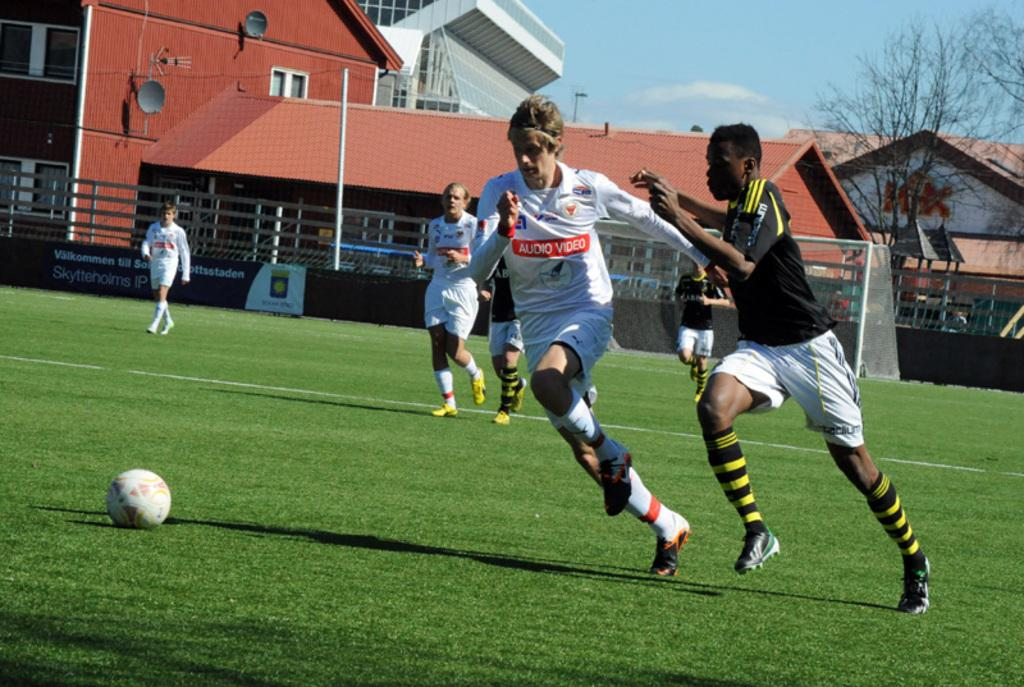<image>
Summarize the visual content of the image. Two soccer players race towards a ball on the field with one in a white jersery reading Audio Video 